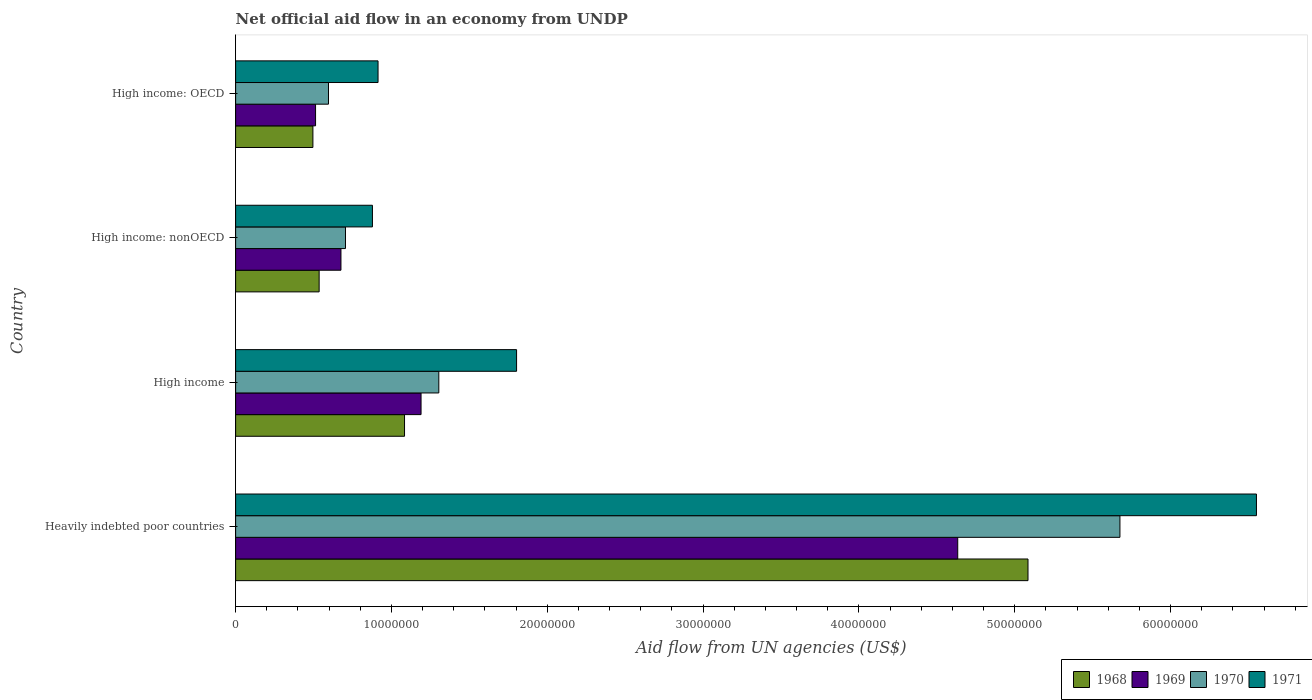How many different coloured bars are there?
Give a very brief answer. 4. How many groups of bars are there?
Provide a short and direct response. 4. Are the number of bars on each tick of the Y-axis equal?
Your answer should be compact. Yes. How many bars are there on the 2nd tick from the top?
Keep it short and to the point. 4. How many bars are there on the 4th tick from the bottom?
Offer a very short reply. 4. What is the label of the 3rd group of bars from the top?
Offer a terse response. High income. What is the net official aid flow in 1970 in High income?
Ensure brevity in your answer.  1.30e+07. Across all countries, what is the maximum net official aid flow in 1968?
Provide a succinct answer. 5.08e+07. Across all countries, what is the minimum net official aid flow in 1971?
Your response must be concise. 8.78e+06. In which country was the net official aid flow in 1969 maximum?
Offer a very short reply. Heavily indebted poor countries. In which country was the net official aid flow in 1970 minimum?
Ensure brevity in your answer.  High income: OECD. What is the total net official aid flow in 1971 in the graph?
Make the answer very short. 1.01e+08. What is the difference between the net official aid flow in 1969 in Heavily indebted poor countries and that in High income: OECD?
Keep it short and to the point. 4.12e+07. What is the difference between the net official aid flow in 1969 in High income and the net official aid flow in 1970 in High income: nonOECD?
Your answer should be compact. 4.85e+06. What is the average net official aid flow in 1968 per country?
Ensure brevity in your answer.  1.80e+07. What is the difference between the net official aid flow in 1968 and net official aid flow in 1971 in High income: OECD?
Offer a terse response. -4.18e+06. What is the ratio of the net official aid flow in 1968 in High income to that in High income: OECD?
Offer a terse response. 2.19. Is the difference between the net official aid flow in 1968 in High income and High income: OECD greater than the difference between the net official aid flow in 1971 in High income and High income: OECD?
Your response must be concise. No. What is the difference between the highest and the second highest net official aid flow in 1969?
Offer a terse response. 3.44e+07. What is the difference between the highest and the lowest net official aid flow in 1971?
Keep it short and to the point. 5.67e+07. In how many countries, is the net official aid flow in 1970 greater than the average net official aid flow in 1970 taken over all countries?
Ensure brevity in your answer.  1. Is the sum of the net official aid flow in 1971 in Heavily indebted poor countries and High income greater than the maximum net official aid flow in 1969 across all countries?
Offer a very short reply. Yes. What does the 2nd bar from the bottom in High income: OECD represents?
Keep it short and to the point. 1969. Is it the case that in every country, the sum of the net official aid flow in 1968 and net official aid flow in 1970 is greater than the net official aid flow in 1971?
Provide a short and direct response. Yes. Are all the bars in the graph horizontal?
Keep it short and to the point. Yes. How many countries are there in the graph?
Provide a succinct answer. 4. Are the values on the major ticks of X-axis written in scientific E-notation?
Ensure brevity in your answer.  No. Does the graph contain any zero values?
Your answer should be compact. No. What is the title of the graph?
Provide a short and direct response. Net official aid flow in an economy from UNDP. What is the label or title of the X-axis?
Give a very brief answer. Aid flow from UN agencies (US$). What is the Aid flow from UN agencies (US$) of 1968 in Heavily indebted poor countries?
Make the answer very short. 5.08e+07. What is the Aid flow from UN agencies (US$) of 1969 in Heavily indebted poor countries?
Offer a very short reply. 4.63e+07. What is the Aid flow from UN agencies (US$) of 1970 in Heavily indebted poor countries?
Your response must be concise. 5.68e+07. What is the Aid flow from UN agencies (US$) of 1971 in Heavily indebted poor countries?
Provide a succinct answer. 6.55e+07. What is the Aid flow from UN agencies (US$) in 1968 in High income?
Your answer should be compact. 1.08e+07. What is the Aid flow from UN agencies (US$) in 1969 in High income?
Make the answer very short. 1.19e+07. What is the Aid flow from UN agencies (US$) of 1970 in High income?
Offer a terse response. 1.30e+07. What is the Aid flow from UN agencies (US$) of 1971 in High income?
Ensure brevity in your answer.  1.80e+07. What is the Aid flow from UN agencies (US$) of 1968 in High income: nonOECD?
Ensure brevity in your answer.  5.36e+06. What is the Aid flow from UN agencies (US$) of 1969 in High income: nonOECD?
Keep it short and to the point. 6.76e+06. What is the Aid flow from UN agencies (US$) of 1970 in High income: nonOECD?
Provide a succinct answer. 7.05e+06. What is the Aid flow from UN agencies (US$) in 1971 in High income: nonOECD?
Keep it short and to the point. 8.78e+06. What is the Aid flow from UN agencies (US$) in 1968 in High income: OECD?
Provide a succinct answer. 4.96e+06. What is the Aid flow from UN agencies (US$) of 1969 in High income: OECD?
Give a very brief answer. 5.13e+06. What is the Aid flow from UN agencies (US$) in 1970 in High income: OECD?
Your response must be concise. 5.96e+06. What is the Aid flow from UN agencies (US$) of 1971 in High income: OECD?
Make the answer very short. 9.14e+06. Across all countries, what is the maximum Aid flow from UN agencies (US$) in 1968?
Your answer should be very brief. 5.08e+07. Across all countries, what is the maximum Aid flow from UN agencies (US$) of 1969?
Your response must be concise. 4.63e+07. Across all countries, what is the maximum Aid flow from UN agencies (US$) of 1970?
Ensure brevity in your answer.  5.68e+07. Across all countries, what is the maximum Aid flow from UN agencies (US$) of 1971?
Your response must be concise. 6.55e+07. Across all countries, what is the minimum Aid flow from UN agencies (US$) in 1968?
Your answer should be very brief. 4.96e+06. Across all countries, what is the minimum Aid flow from UN agencies (US$) in 1969?
Ensure brevity in your answer.  5.13e+06. Across all countries, what is the minimum Aid flow from UN agencies (US$) of 1970?
Give a very brief answer. 5.96e+06. Across all countries, what is the minimum Aid flow from UN agencies (US$) of 1971?
Offer a very short reply. 8.78e+06. What is the total Aid flow from UN agencies (US$) of 1968 in the graph?
Offer a terse response. 7.20e+07. What is the total Aid flow from UN agencies (US$) of 1969 in the graph?
Make the answer very short. 7.01e+07. What is the total Aid flow from UN agencies (US$) of 1970 in the graph?
Your response must be concise. 8.28e+07. What is the total Aid flow from UN agencies (US$) in 1971 in the graph?
Your answer should be very brief. 1.01e+08. What is the difference between the Aid flow from UN agencies (US$) of 1968 in Heavily indebted poor countries and that in High income?
Provide a succinct answer. 4.00e+07. What is the difference between the Aid flow from UN agencies (US$) in 1969 in Heavily indebted poor countries and that in High income?
Offer a very short reply. 3.44e+07. What is the difference between the Aid flow from UN agencies (US$) in 1970 in Heavily indebted poor countries and that in High income?
Offer a terse response. 4.37e+07. What is the difference between the Aid flow from UN agencies (US$) in 1971 in Heavily indebted poor countries and that in High income?
Offer a very short reply. 4.75e+07. What is the difference between the Aid flow from UN agencies (US$) of 1968 in Heavily indebted poor countries and that in High income: nonOECD?
Your answer should be compact. 4.55e+07. What is the difference between the Aid flow from UN agencies (US$) in 1969 in Heavily indebted poor countries and that in High income: nonOECD?
Provide a succinct answer. 3.96e+07. What is the difference between the Aid flow from UN agencies (US$) in 1970 in Heavily indebted poor countries and that in High income: nonOECD?
Ensure brevity in your answer.  4.97e+07. What is the difference between the Aid flow from UN agencies (US$) of 1971 in Heavily indebted poor countries and that in High income: nonOECD?
Provide a succinct answer. 5.67e+07. What is the difference between the Aid flow from UN agencies (US$) in 1968 in Heavily indebted poor countries and that in High income: OECD?
Keep it short and to the point. 4.59e+07. What is the difference between the Aid flow from UN agencies (US$) of 1969 in Heavily indebted poor countries and that in High income: OECD?
Offer a very short reply. 4.12e+07. What is the difference between the Aid flow from UN agencies (US$) of 1970 in Heavily indebted poor countries and that in High income: OECD?
Provide a succinct answer. 5.08e+07. What is the difference between the Aid flow from UN agencies (US$) of 1971 in Heavily indebted poor countries and that in High income: OECD?
Offer a terse response. 5.64e+07. What is the difference between the Aid flow from UN agencies (US$) of 1968 in High income and that in High income: nonOECD?
Ensure brevity in your answer.  5.48e+06. What is the difference between the Aid flow from UN agencies (US$) in 1969 in High income and that in High income: nonOECD?
Your answer should be very brief. 5.14e+06. What is the difference between the Aid flow from UN agencies (US$) of 1970 in High income and that in High income: nonOECD?
Offer a terse response. 5.99e+06. What is the difference between the Aid flow from UN agencies (US$) in 1971 in High income and that in High income: nonOECD?
Give a very brief answer. 9.25e+06. What is the difference between the Aid flow from UN agencies (US$) in 1968 in High income and that in High income: OECD?
Provide a short and direct response. 5.88e+06. What is the difference between the Aid flow from UN agencies (US$) in 1969 in High income and that in High income: OECD?
Ensure brevity in your answer.  6.77e+06. What is the difference between the Aid flow from UN agencies (US$) of 1970 in High income and that in High income: OECD?
Provide a succinct answer. 7.08e+06. What is the difference between the Aid flow from UN agencies (US$) in 1971 in High income and that in High income: OECD?
Keep it short and to the point. 8.89e+06. What is the difference between the Aid flow from UN agencies (US$) in 1968 in High income: nonOECD and that in High income: OECD?
Keep it short and to the point. 4.00e+05. What is the difference between the Aid flow from UN agencies (US$) of 1969 in High income: nonOECD and that in High income: OECD?
Provide a short and direct response. 1.63e+06. What is the difference between the Aid flow from UN agencies (US$) of 1970 in High income: nonOECD and that in High income: OECD?
Provide a short and direct response. 1.09e+06. What is the difference between the Aid flow from UN agencies (US$) of 1971 in High income: nonOECD and that in High income: OECD?
Provide a succinct answer. -3.60e+05. What is the difference between the Aid flow from UN agencies (US$) of 1968 in Heavily indebted poor countries and the Aid flow from UN agencies (US$) of 1969 in High income?
Offer a terse response. 3.90e+07. What is the difference between the Aid flow from UN agencies (US$) in 1968 in Heavily indebted poor countries and the Aid flow from UN agencies (US$) in 1970 in High income?
Make the answer very short. 3.78e+07. What is the difference between the Aid flow from UN agencies (US$) of 1968 in Heavily indebted poor countries and the Aid flow from UN agencies (US$) of 1971 in High income?
Make the answer very short. 3.28e+07. What is the difference between the Aid flow from UN agencies (US$) in 1969 in Heavily indebted poor countries and the Aid flow from UN agencies (US$) in 1970 in High income?
Make the answer very short. 3.33e+07. What is the difference between the Aid flow from UN agencies (US$) of 1969 in Heavily indebted poor countries and the Aid flow from UN agencies (US$) of 1971 in High income?
Your answer should be very brief. 2.83e+07. What is the difference between the Aid flow from UN agencies (US$) in 1970 in Heavily indebted poor countries and the Aid flow from UN agencies (US$) in 1971 in High income?
Give a very brief answer. 3.87e+07. What is the difference between the Aid flow from UN agencies (US$) in 1968 in Heavily indebted poor countries and the Aid flow from UN agencies (US$) in 1969 in High income: nonOECD?
Offer a very short reply. 4.41e+07. What is the difference between the Aid flow from UN agencies (US$) of 1968 in Heavily indebted poor countries and the Aid flow from UN agencies (US$) of 1970 in High income: nonOECD?
Your response must be concise. 4.38e+07. What is the difference between the Aid flow from UN agencies (US$) in 1968 in Heavily indebted poor countries and the Aid flow from UN agencies (US$) in 1971 in High income: nonOECD?
Your answer should be very brief. 4.21e+07. What is the difference between the Aid flow from UN agencies (US$) of 1969 in Heavily indebted poor countries and the Aid flow from UN agencies (US$) of 1970 in High income: nonOECD?
Your answer should be very brief. 3.93e+07. What is the difference between the Aid flow from UN agencies (US$) in 1969 in Heavily indebted poor countries and the Aid flow from UN agencies (US$) in 1971 in High income: nonOECD?
Give a very brief answer. 3.76e+07. What is the difference between the Aid flow from UN agencies (US$) in 1970 in Heavily indebted poor countries and the Aid flow from UN agencies (US$) in 1971 in High income: nonOECD?
Ensure brevity in your answer.  4.80e+07. What is the difference between the Aid flow from UN agencies (US$) in 1968 in Heavily indebted poor countries and the Aid flow from UN agencies (US$) in 1969 in High income: OECD?
Offer a very short reply. 4.57e+07. What is the difference between the Aid flow from UN agencies (US$) of 1968 in Heavily indebted poor countries and the Aid flow from UN agencies (US$) of 1970 in High income: OECD?
Ensure brevity in your answer.  4.49e+07. What is the difference between the Aid flow from UN agencies (US$) in 1968 in Heavily indebted poor countries and the Aid flow from UN agencies (US$) in 1971 in High income: OECD?
Offer a terse response. 4.17e+07. What is the difference between the Aid flow from UN agencies (US$) of 1969 in Heavily indebted poor countries and the Aid flow from UN agencies (US$) of 1970 in High income: OECD?
Give a very brief answer. 4.04e+07. What is the difference between the Aid flow from UN agencies (US$) in 1969 in Heavily indebted poor countries and the Aid flow from UN agencies (US$) in 1971 in High income: OECD?
Give a very brief answer. 3.72e+07. What is the difference between the Aid flow from UN agencies (US$) in 1970 in Heavily indebted poor countries and the Aid flow from UN agencies (US$) in 1971 in High income: OECD?
Provide a succinct answer. 4.76e+07. What is the difference between the Aid flow from UN agencies (US$) in 1968 in High income and the Aid flow from UN agencies (US$) in 1969 in High income: nonOECD?
Offer a very short reply. 4.08e+06. What is the difference between the Aid flow from UN agencies (US$) of 1968 in High income and the Aid flow from UN agencies (US$) of 1970 in High income: nonOECD?
Provide a succinct answer. 3.79e+06. What is the difference between the Aid flow from UN agencies (US$) in 1968 in High income and the Aid flow from UN agencies (US$) in 1971 in High income: nonOECD?
Provide a succinct answer. 2.06e+06. What is the difference between the Aid flow from UN agencies (US$) in 1969 in High income and the Aid flow from UN agencies (US$) in 1970 in High income: nonOECD?
Your answer should be compact. 4.85e+06. What is the difference between the Aid flow from UN agencies (US$) of 1969 in High income and the Aid flow from UN agencies (US$) of 1971 in High income: nonOECD?
Your answer should be compact. 3.12e+06. What is the difference between the Aid flow from UN agencies (US$) in 1970 in High income and the Aid flow from UN agencies (US$) in 1971 in High income: nonOECD?
Your answer should be compact. 4.26e+06. What is the difference between the Aid flow from UN agencies (US$) of 1968 in High income and the Aid flow from UN agencies (US$) of 1969 in High income: OECD?
Keep it short and to the point. 5.71e+06. What is the difference between the Aid flow from UN agencies (US$) of 1968 in High income and the Aid flow from UN agencies (US$) of 1970 in High income: OECD?
Offer a terse response. 4.88e+06. What is the difference between the Aid flow from UN agencies (US$) in 1968 in High income and the Aid flow from UN agencies (US$) in 1971 in High income: OECD?
Ensure brevity in your answer.  1.70e+06. What is the difference between the Aid flow from UN agencies (US$) of 1969 in High income and the Aid flow from UN agencies (US$) of 1970 in High income: OECD?
Offer a very short reply. 5.94e+06. What is the difference between the Aid flow from UN agencies (US$) in 1969 in High income and the Aid flow from UN agencies (US$) in 1971 in High income: OECD?
Offer a very short reply. 2.76e+06. What is the difference between the Aid flow from UN agencies (US$) in 1970 in High income and the Aid flow from UN agencies (US$) in 1971 in High income: OECD?
Your answer should be compact. 3.90e+06. What is the difference between the Aid flow from UN agencies (US$) of 1968 in High income: nonOECD and the Aid flow from UN agencies (US$) of 1969 in High income: OECD?
Ensure brevity in your answer.  2.30e+05. What is the difference between the Aid flow from UN agencies (US$) of 1968 in High income: nonOECD and the Aid flow from UN agencies (US$) of 1970 in High income: OECD?
Keep it short and to the point. -6.00e+05. What is the difference between the Aid flow from UN agencies (US$) in 1968 in High income: nonOECD and the Aid flow from UN agencies (US$) in 1971 in High income: OECD?
Offer a terse response. -3.78e+06. What is the difference between the Aid flow from UN agencies (US$) of 1969 in High income: nonOECD and the Aid flow from UN agencies (US$) of 1970 in High income: OECD?
Your answer should be very brief. 8.00e+05. What is the difference between the Aid flow from UN agencies (US$) in 1969 in High income: nonOECD and the Aid flow from UN agencies (US$) in 1971 in High income: OECD?
Your answer should be very brief. -2.38e+06. What is the difference between the Aid flow from UN agencies (US$) of 1970 in High income: nonOECD and the Aid flow from UN agencies (US$) of 1971 in High income: OECD?
Ensure brevity in your answer.  -2.09e+06. What is the average Aid flow from UN agencies (US$) of 1968 per country?
Ensure brevity in your answer.  1.80e+07. What is the average Aid flow from UN agencies (US$) of 1969 per country?
Make the answer very short. 1.75e+07. What is the average Aid flow from UN agencies (US$) of 1970 per country?
Offer a terse response. 2.07e+07. What is the average Aid flow from UN agencies (US$) of 1971 per country?
Make the answer very short. 2.54e+07. What is the difference between the Aid flow from UN agencies (US$) of 1968 and Aid flow from UN agencies (US$) of 1969 in Heavily indebted poor countries?
Offer a very short reply. 4.51e+06. What is the difference between the Aid flow from UN agencies (US$) of 1968 and Aid flow from UN agencies (US$) of 1970 in Heavily indebted poor countries?
Offer a very short reply. -5.90e+06. What is the difference between the Aid flow from UN agencies (US$) of 1968 and Aid flow from UN agencies (US$) of 1971 in Heavily indebted poor countries?
Provide a succinct answer. -1.47e+07. What is the difference between the Aid flow from UN agencies (US$) in 1969 and Aid flow from UN agencies (US$) in 1970 in Heavily indebted poor countries?
Provide a short and direct response. -1.04e+07. What is the difference between the Aid flow from UN agencies (US$) of 1969 and Aid flow from UN agencies (US$) of 1971 in Heavily indebted poor countries?
Offer a terse response. -1.92e+07. What is the difference between the Aid flow from UN agencies (US$) in 1970 and Aid flow from UN agencies (US$) in 1971 in Heavily indebted poor countries?
Your answer should be compact. -8.76e+06. What is the difference between the Aid flow from UN agencies (US$) of 1968 and Aid flow from UN agencies (US$) of 1969 in High income?
Your answer should be compact. -1.06e+06. What is the difference between the Aid flow from UN agencies (US$) in 1968 and Aid flow from UN agencies (US$) in 1970 in High income?
Give a very brief answer. -2.20e+06. What is the difference between the Aid flow from UN agencies (US$) in 1968 and Aid flow from UN agencies (US$) in 1971 in High income?
Offer a terse response. -7.19e+06. What is the difference between the Aid flow from UN agencies (US$) in 1969 and Aid flow from UN agencies (US$) in 1970 in High income?
Your response must be concise. -1.14e+06. What is the difference between the Aid flow from UN agencies (US$) of 1969 and Aid flow from UN agencies (US$) of 1971 in High income?
Make the answer very short. -6.13e+06. What is the difference between the Aid flow from UN agencies (US$) of 1970 and Aid flow from UN agencies (US$) of 1971 in High income?
Provide a succinct answer. -4.99e+06. What is the difference between the Aid flow from UN agencies (US$) of 1968 and Aid flow from UN agencies (US$) of 1969 in High income: nonOECD?
Give a very brief answer. -1.40e+06. What is the difference between the Aid flow from UN agencies (US$) in 1968 and Aid flow from UN agencies (US$) in 1970 in High income: nonOECD?
Make the answer very short. -1.69e+06. What is the difference between the Aid flow from UN agencies (US$) of 1968 and Aid flow from UN agencies (US$) of 1971 in High income: nonOECD?
Your response must be concise. -3.42e+06. What is the difference between the Aid flow from UN agencies (US$) in 1969 and Aid flow from UN agencies (US$) in 1971 in High income: nonOECD?
Your answer should be very brief. -2.02e+06. What is the difference between the Aid flow from UN agencies (US$) in 1970 and Aid flow from UN agencies (US$) in 1971 in High income: nonOECD?
Your answer should be compact. -1.73e+06. What is the difference between the Aid flow from UN agencies (US$) in 1968 and Aid flow from UN agencies (US$) in 1969 in High income: OECD?
Provide a short and direct response. -1.70e+05. What is the difference between the Aid flow from UN agencies (US$) in 1968 and Aid flow from UN agencies (US$) in 1970 in High income: OECD?
Your response must be concise. -1.00e+06. What is the difference between the Aid flow from UN agencies (US$) of 1968 and Aid flow from UN agencies (US$) of 1971 in High income: OECD?
Give a very brief answer. -4.18e+06. What is the difference between the Aid flow from UN agencies (US$) in 1969 and Aid flow from UN agencies (US$) in 1970 in High income: OECD?
Your response must be concise. -8.30e+05. What is the difference between the Aid flow from UN agencies (US$) in 1969 and Aid flow from UN agencies (US$) in 1971 in High income: OECD?
Offer a terse response. -4.01e+06. What is the difference between the Aid flow from UN agencies (US$) of 1970 and Aid flow from UN agencies (US$) of 1971 in High income: OECD?
Provide a short and direct response. -3.18e+06. What is the ratio of the Aid flow from UN agencies (US$) in 1968 in Heavily indebted poor countries to that in High income?
Offer a very short reply. 4.69. What is the ratio of the Aid flow from UN agencies (US$) of 1969 in Heavily indebted poor countries to that in High income?
Provide a short and direct response. 3.89. What is the ratio of the Aid flow from UN agencies (US$) of 1970 in Heavily indebted poor countries to that in High income?
Your answer should be compact. 4.35. What is the ratio of the Aid flow from UN agencies (US$) in 1971 in Heavily indebted poor countries to that in High income?
Keep it short and to the point. 3.63. What is the ratio of the Aid flow from UN agencies (US$) in 1968 in Heavily indebted poor countries to that in High income: nonOECD?
Offer a terse response. 9.49. What is the ratio of the Aid flow from UN agencies (US$) of 1969 in Heavily indebted poor countries to that in High income: nonOECD?
Offer a terse response. 6.86. What is the ratio of the Aid flow from UN agencies (US$) in 1970 in Heavily indebted poor countries to that in High income: nonOECD?
Offer a terse response. 8.05. What is the ratio of the Aid flow from UN agencies (US$) in 1971 in Heavily indebted poor countries to that in High income: nonOECD?
Give a very brief answer. 7.46. What is the ratio of the Aid flow from UN agencies (US$) of 1968 in Heavily indebted poor countries to that in High income: OECD?
Provide a short and direct response. 10.25. What is the ratio of the Aid flow from UN agencies (US$) of 1969 in Heavily indebted poor countries to that in High income: OECD?
Keep it short and to the point. 9.03. What is the ratio of the Aid flow from UN agencies (US$) of 1970 in Heavily indebted poor countries to that in High income: OECD?
Give a very brief answer. 9.52. What is the ratio of the Aid flow from UN agencies (US$) of 1971 in Heavily indebted poor countries to that in High income: OECD?
Your response must be concise. 7.17. What is the ratio of the Aid flow from UN agencies (US$) of 1968 in High income to that in High income: nonOECD?
Provide a succinct answer. 2.02. What is the ratio of the Aid flow from UN agencies (US$) in 1969 in High income to that in High income: nonOECD?
Make the answer very short. 1.76. What is the ratio of the Aid flow from UN agencies (US$) of 1970 in High income to that in High income: nonOECD?
Ensure brevity in your answer.  1.85. What is the ratio of the Aid flow from UN agencies (US$) in 1971 in High income to that in High income: nonOECD?
Your answer should be very brief. 2.05. What is the ratio of the Aid flow from UN agencies (US$) in 1968 in High income to that in High income: OECD?
Your response must be concise. 2.19. What is the ratio of the Aid flow from UN agencies (US$) of 1969 in High income to that in High income: OECD?
Provide a succinct answer. 2.32. What is the ratio of the Aid flow from UN agencies (US$) in 1970 in High income to that in High income: OECD?
Give a very brief answer. 2.19. What is the ratio of the Aid flow from UN agencies (US$) of 1971 in High income to that in High income: OECD?
Keep it short and to the point. 1.97. What is the ratio of the Aid flow from UN agencies (US$) of 1968 in High income: nonOECD to that in High income: OECD?
Ensure brevity in your answer.  1.08. What is the ratio of the Aid flow from UN agencies (US$) in 1969 in High income: nonOECD to that in High income: OECD?
Give a very brief answer. 1.32. What is the ratio of the Aid flow from UN agencies (US$) of 1970 in High income: nonOECD to that in High income: OECD?
Your answer should be compact. 1.18. What is the ratio of the Aid flow from UN agencies (US$) in 1971 in High income: nonOECD to that in High income: OECD?
Your response must be concise. 0.96. What is the difference between the highest and the second highest Aid flow from UN agencies (US$) in 1968?
Provide a short and direct response. 4.00e+07. What is the difference between the highest and the second highest Aid flow from UN agencies (US$) of 1969?
Your answer should be compact. 3.44e+07. What is the difference between the highest and the second highest Aid flow from UN agencies (US$) of 1970?
Keep it short and to the point. 4.37e+07. What is the difference between the highest and the second highest Aid flow from UN agencies (US$) in 1971?
Offer a very short reply. 4.75e+07. What is the difference between the highest and the lowest Aid flow from UN agencies (US$) of 1968?
Provide a succinct answer. 4.59e+07. What is the difference between the highest and the lowest Aid flow from UN agencies (US$) of 1969?
Provide a short and direct response. 4.12e+07. What is the difference between the highest and the lowest Aid flow from UN agencies (US$) in 1970?
Your answer should be very brief. 5.08e+07. What is the difference between the highest and the lowest Aid flow from UN agencies (US$) of 1971?
Offer a very short reply. 5.67e+07. 